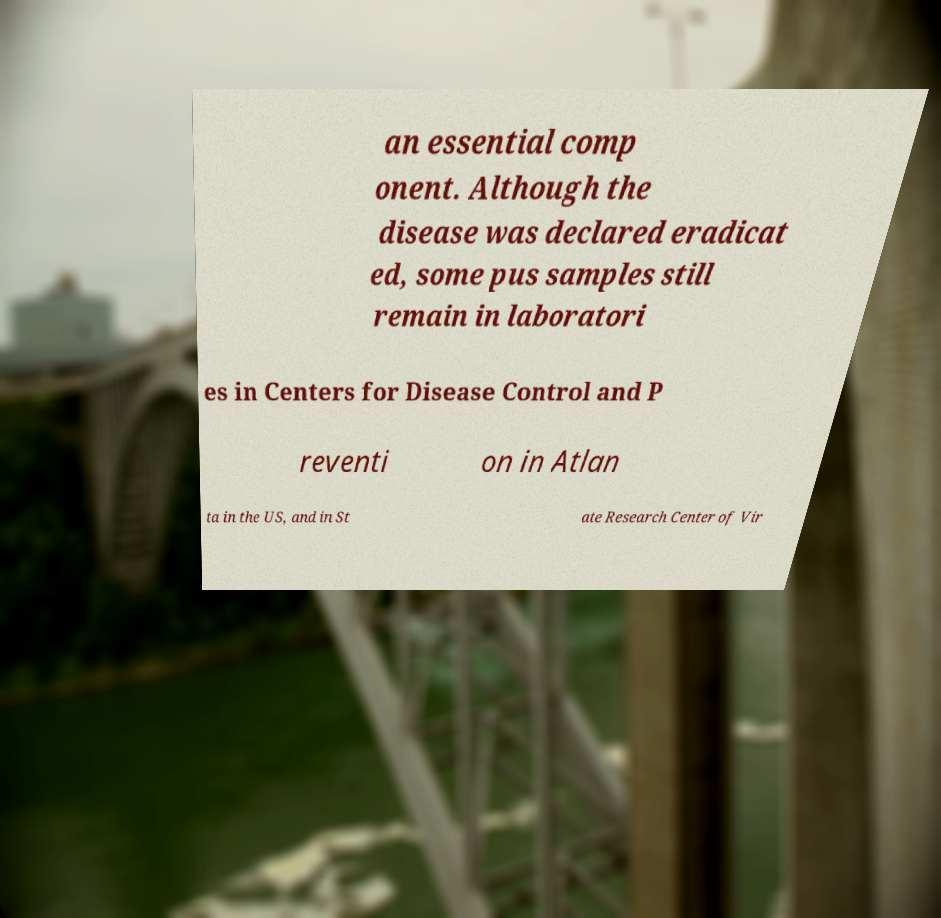Please read and relay the text visible in this image. What does it say? an essential comp onent. Although the disease was declared eradicat ed, some pus samples still remain in laboratori es in Centers for Disease Control and P reventi on in Atlan ta in the US, and in St ate Research Center of Vir 